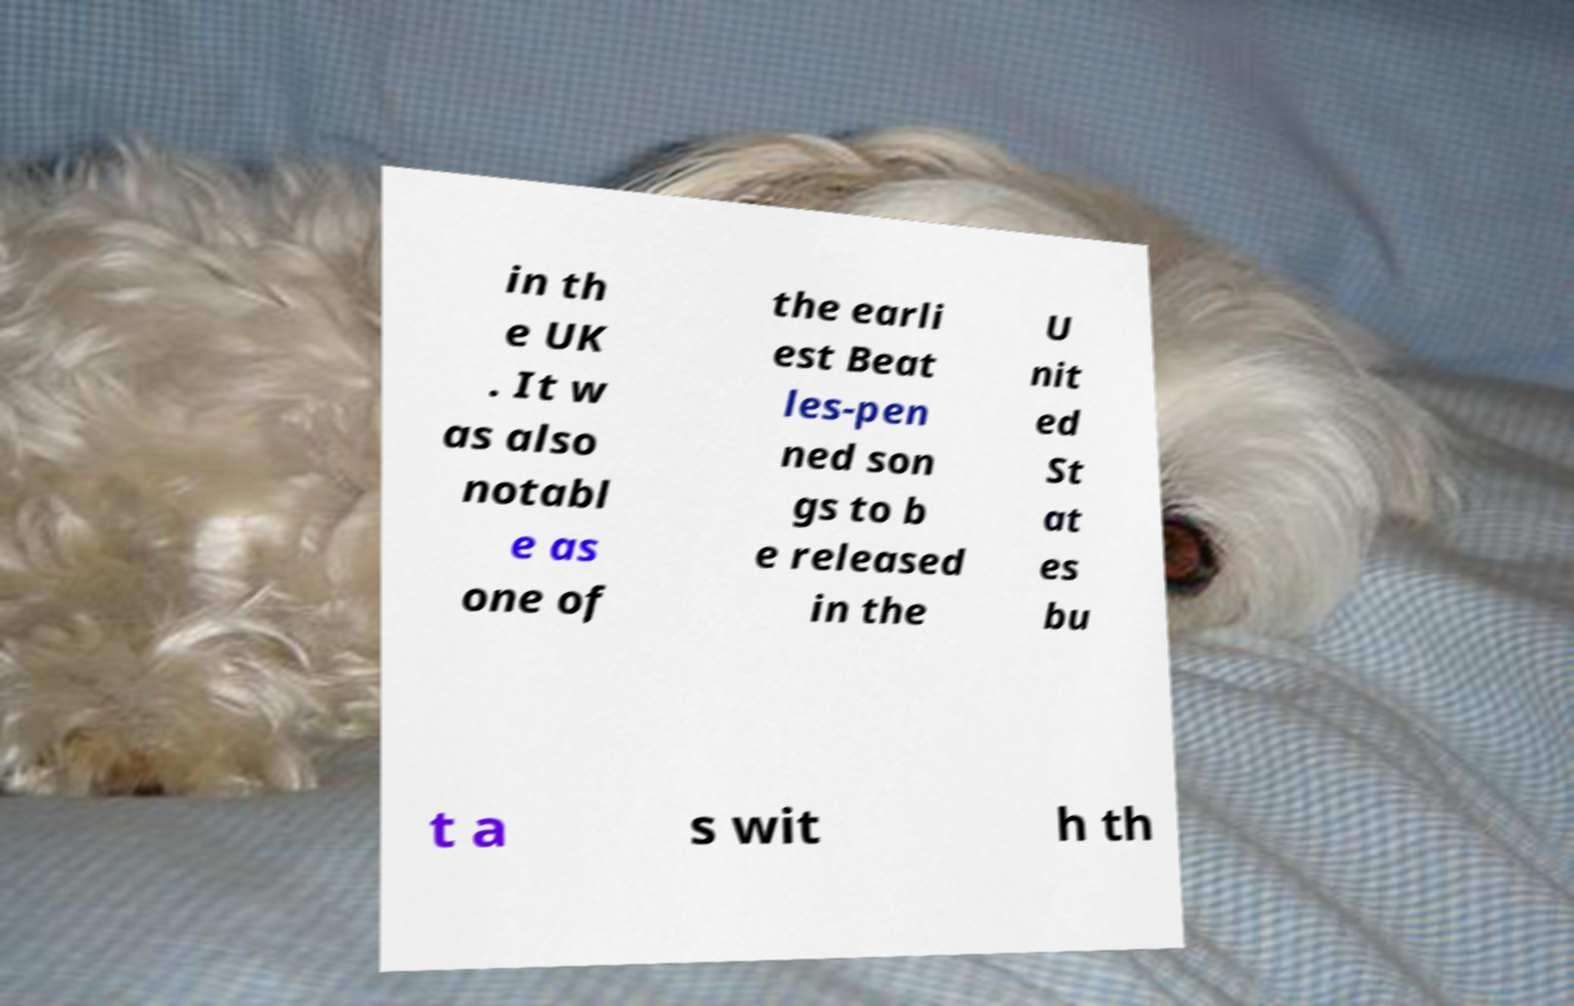Please read and relay the text visible in this image. What does it say? in th e UK . It w as also notabl e as one of the earli est Beat les-pen ned son gs to b e released in the U nit ed St at es bu t a s wit h th 